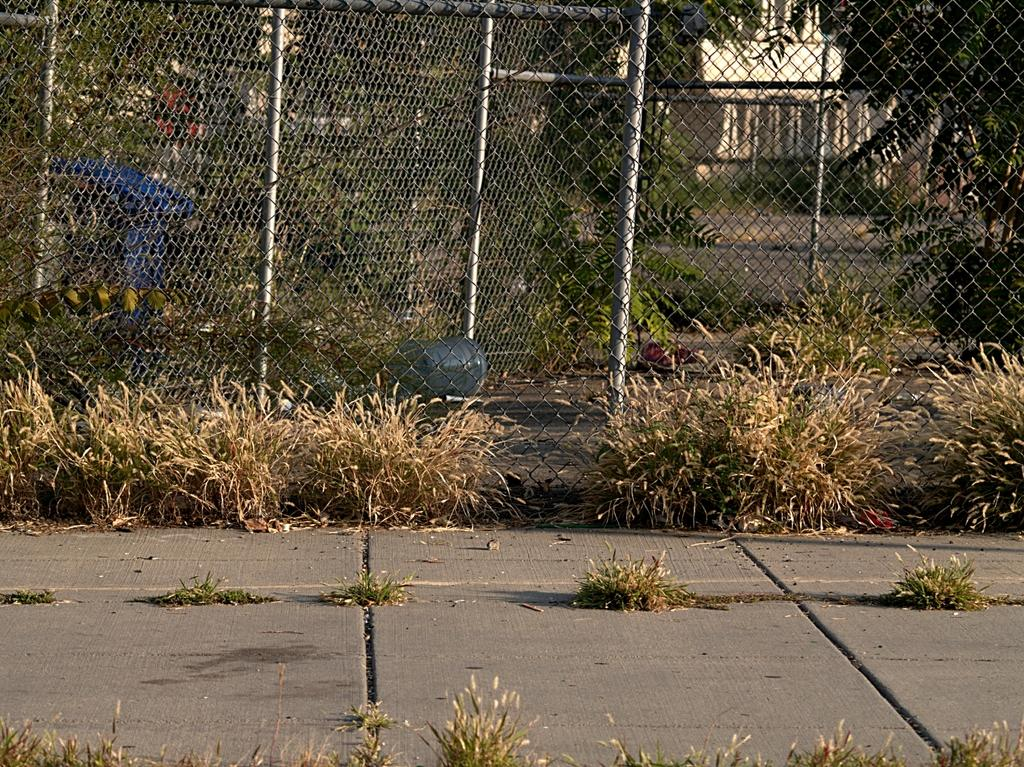What type of living organisms can be seen in the image? Plants can be seen in the image. What structure is present in the image that separates areas? There is a fence in the image. What can be seen through the fence in the image? Trees are visible through the fence. What type of architectural feature is present in the image? There is a wall in the image. What type of container is visible in the image? There is a blue color bin in the image. What type of prose is being recited by the plants in the image? There is no indication in the image that the plants are reciting any prose. What type of steel is used to construct the fence in the image? The image does not provide information about the material used to construct the fence. 